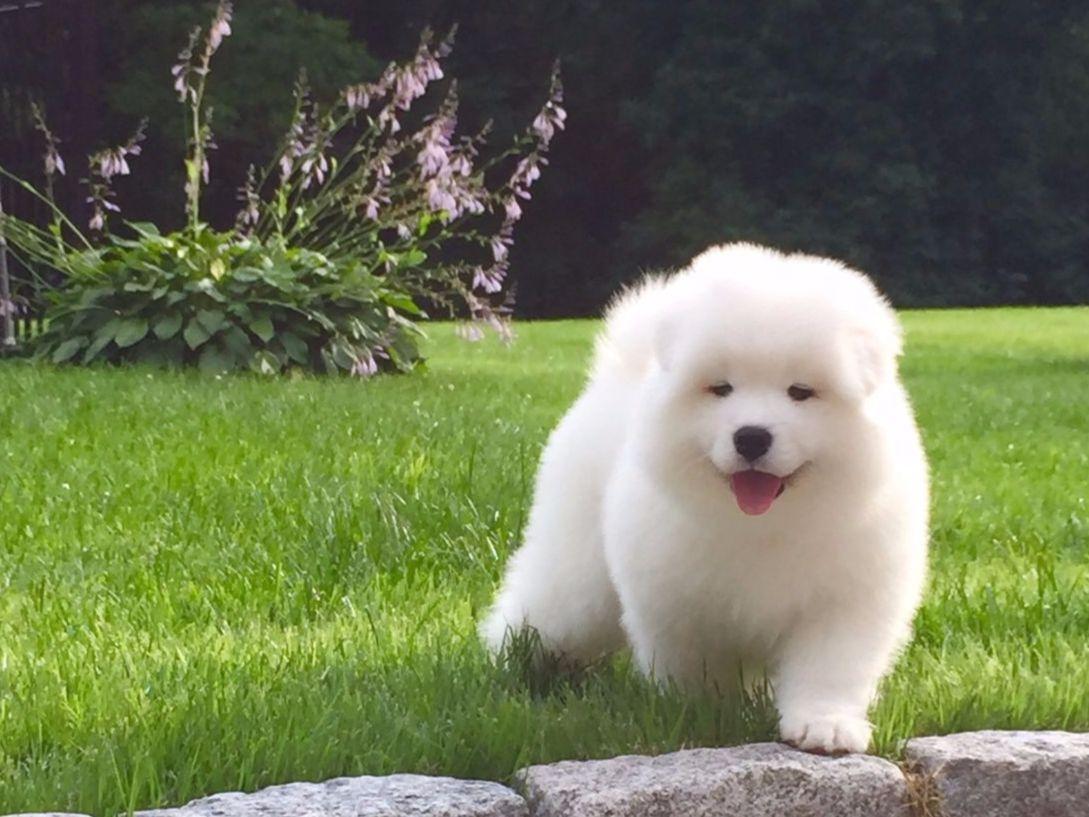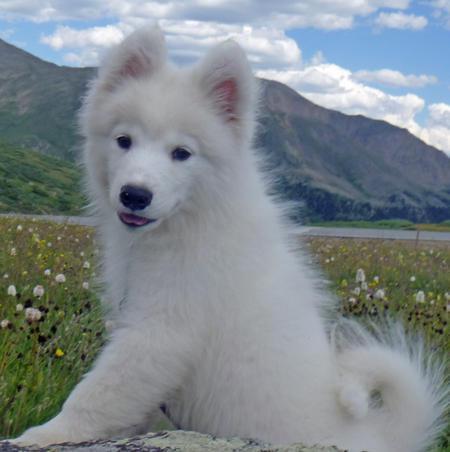The first image is the image on the left, the second image is the image on the right. Considering the images on both sides, is "A white dog has a colored canvas bag strapped to its back in one image, while the other image is of multiple dogs with no bags." valid? Answer yes or no. No. The first image is the image on the left, the second image is the image on the right. Analyze the images presented: Is the assertion "An image shows a rightward facing dog wearing a pack." valid? Answer yes or no. No. 